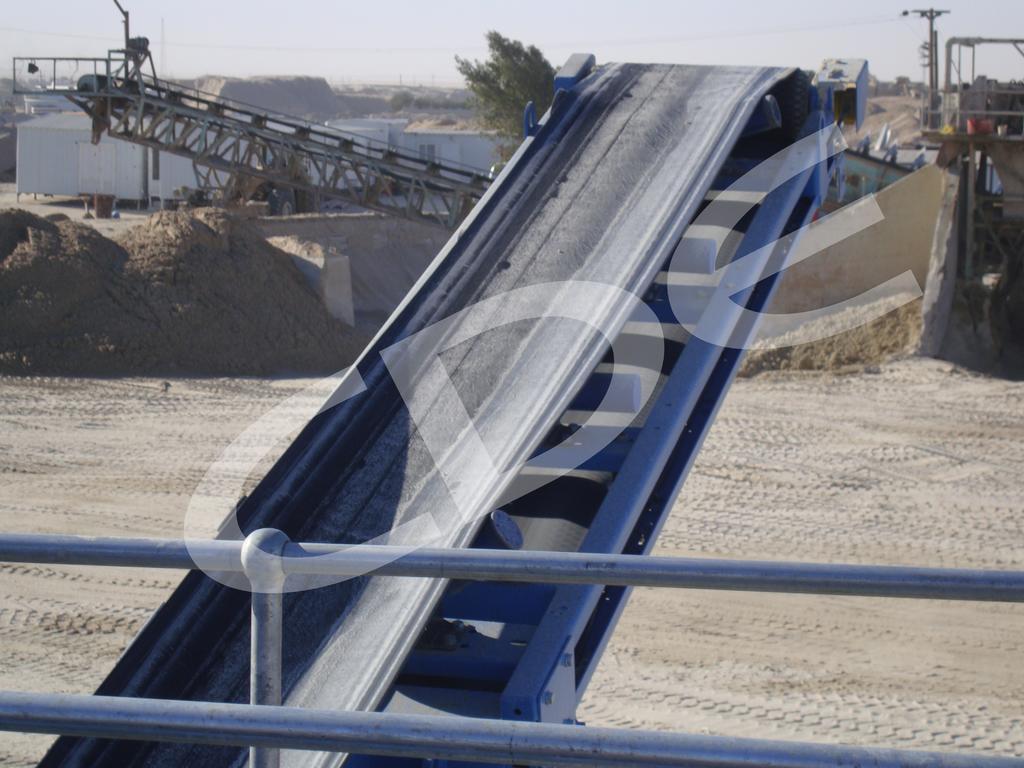Describe this image in one or two sentences. In this image I can see an object in blue and grey color, background I can see few vehicles, trees in green color and I can also see the water, few poles and the sky is in white color. 